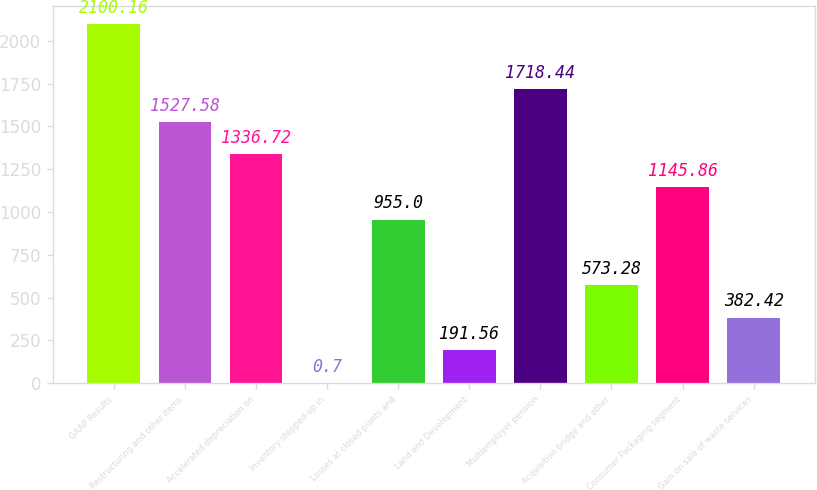Convert chart. <chart><loc_0><loc_0><loc_500><loc_500><bar_chart><fcel>GAAP Results<fcel>Restructuring and other items<fcel>Accelerated depreciation on<fcel>Inventory stepped-up in<fcel>Losses at closed plants and<fcel>Land and Development<fcel>Multiemployer pension<fcel>Acquisition bridge and other<fcel>Consumer Packaging segment<fcel>Gain on sale of waste services<nl><fcel>2100.16<fcel>1527.58<fcel>1336.72<fcel>0.7<fcel>955<fcel>191.56<fcel>1718.44<fcel>573.28<fcel>1145.86<fcel>382.42<nl></chart> 